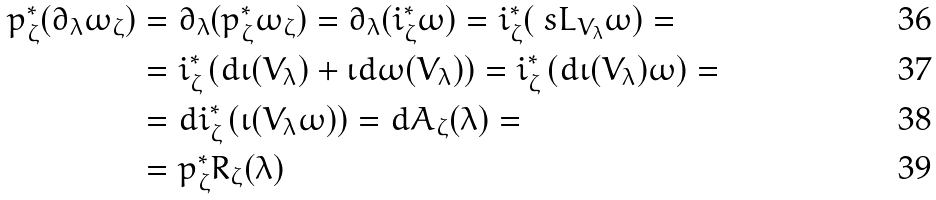Convert formula to latex. <formula><loc_0><loc_0><loc_500><loc_500>p _ { \zeta } ^ { * } ( \partial _ { \lambda } \omega _ { \zeta } ) & = \partial _ { \lambda } ( p _ { \zeta } ^ { * } \omega _ { \zeta } ) = \partial _ { \lambda } ( i _ { \zeta } ^ { * } \omega ) = i _ { \zeta } ^ { * } ( \ s L _ { V _ { \lambda } } \omega ) = \\ & = i _ { \zeta } ^ { * } \left ( d \iota ( V _ { \lambda } ) + \iota d \omega ( V _ { \lambda } ) \right ) = i _ { \zeta } ^ { * } \left ( d \iota ( V _ { \lambda } ) \omega \right ) = \\ & = d i _ { \zeta } ^ { * } \left ( \iota ( V _ { \lambda } \omega ) \right ) = d A _ { \zeta } ( \lambda ) = \\ & = p _ { \zeta } ^ { * } R _ { \zeta } ( \lambda )</formula> 